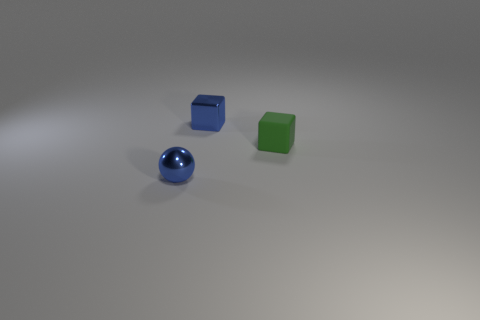There is a object that is both to the left of the green block and right of the shiny ball; what is it made of?
Offer a terse response. Metal. Does the tiny blue sphere have the same material as the small green thing?
Ensure brevity in your answer.  No. How many blue shiny objects have the same size as the shiny ball?
Your answer should be very brief. 1. Are there an equal number of matte cubes behind the green matte cube and metal things?
Your answer should be compact. No. What number of objects are in front of the blue cube and behind the green matte block?
Your answer should be very brief. 0. Is the shape of the tiny blue metal thing on the left side of the tiny metal block the same as  the green rubber thing?
Ensure brevity in your answer.  No. There is a green cube that is the same size as the blue metallic ball; what is its material?
Offer a terse response. Rubber. Is the number of metallic balls that are on the left side of the blue ball the same as the number of blue cubes in front of the shiny cube?
Your answer should be very brief. Yes. There is a thing left of the metal thing that is to the right of the small shiny sphere; what number of small green objects are to the right of it?
Provide a succinct answer. 1. Is the color of the matte cube the same as the metal object that is behind the green matte block?
Provide a succinct answer. No. 